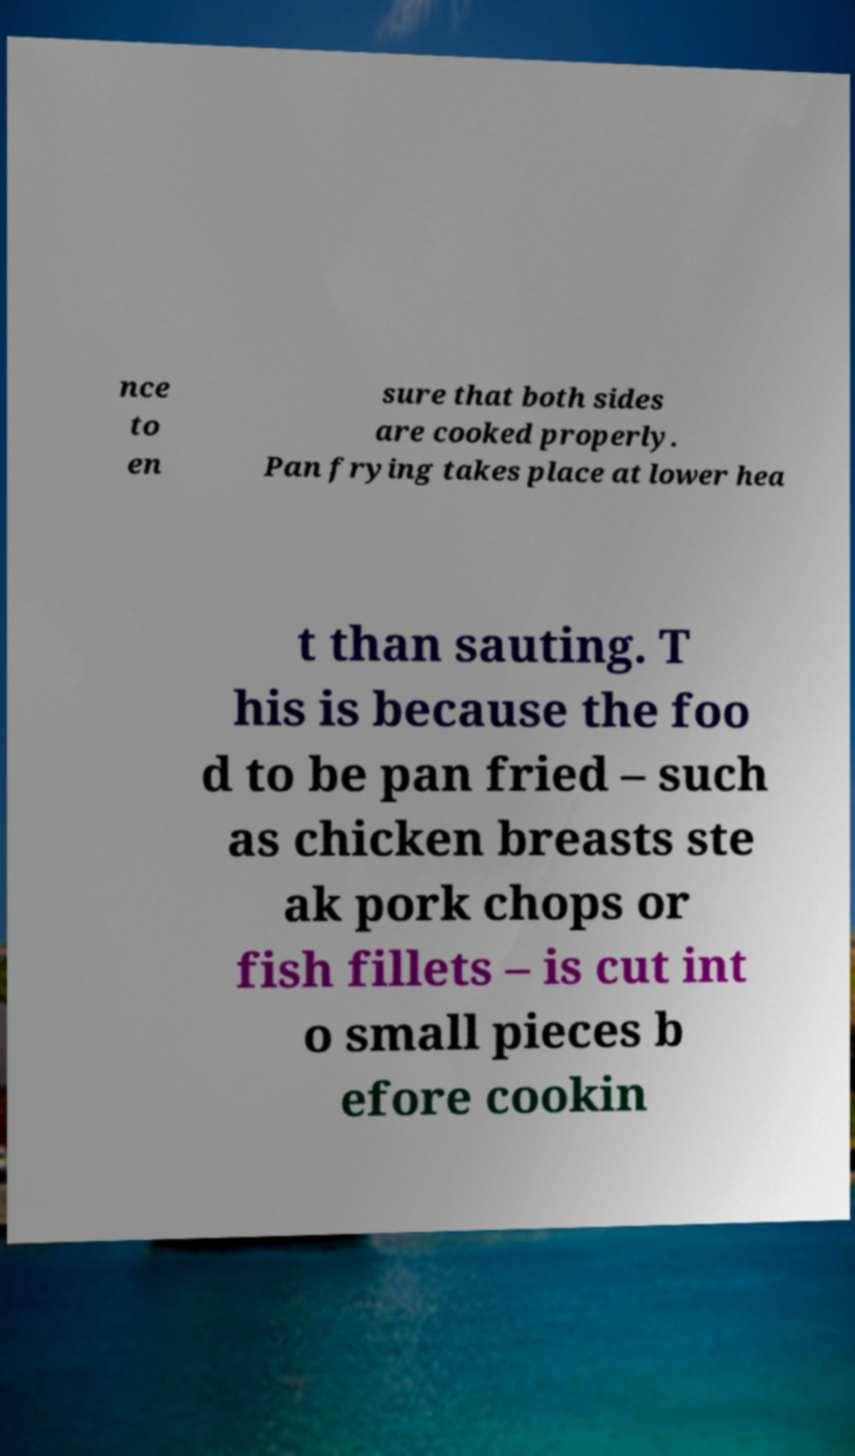Can you read and provide the text displayed in the image?This photo seems to have some interesting text. Can you extract and type it out for me? nce to en sure that both sides are cooked properly. Pan frying takes place at lower hea t than sauting. T his is because the foo d to be pan fried – such as chicken breasts ste ak pork chops or fish fillets – is cut int o small pieces b efore cookin 